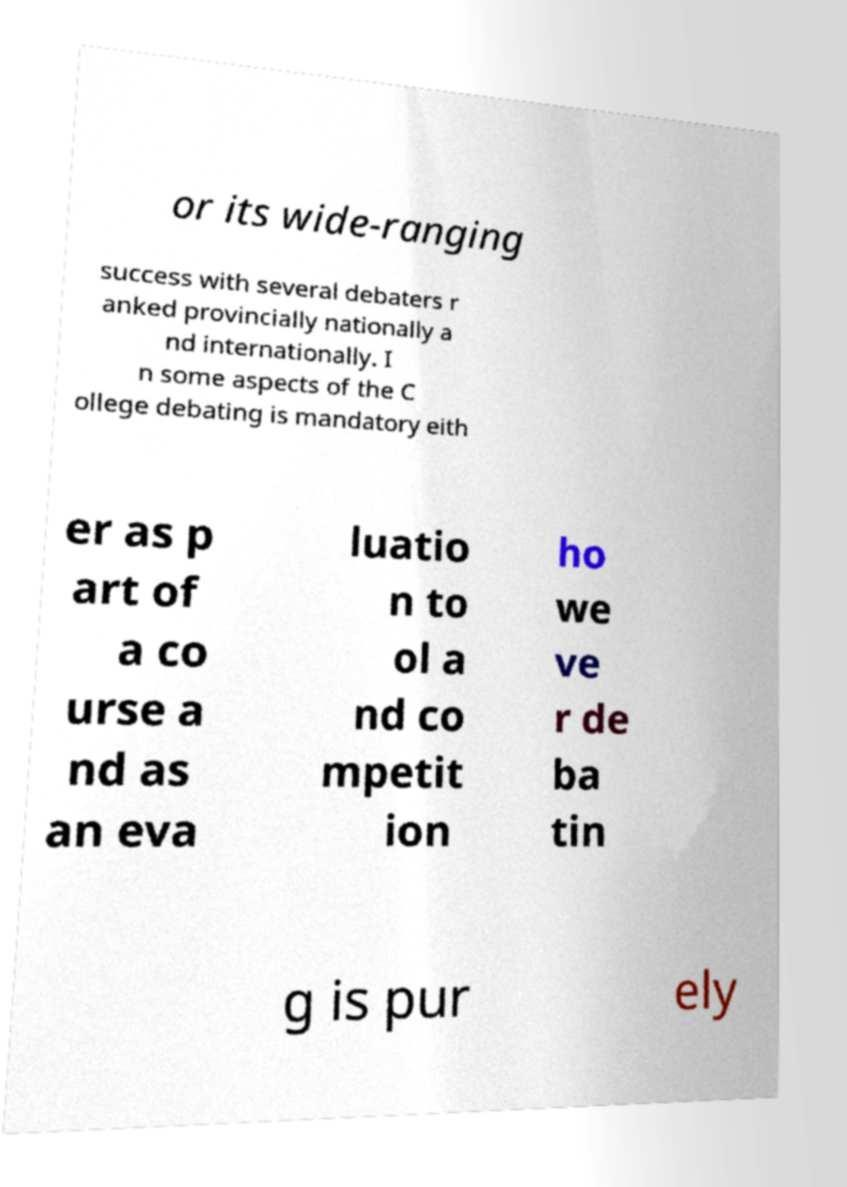What messages or text are displayed in this image? I need them in a readable, typed format. or its wide-ranging success with several debaters r anked provincially nationally a nd internationally. I n some aspects of the C ollege debating is mandatory eith er as p art of a co urse a nd as an eva luatio n to ol a nd co mpetit ion ho we ve r de ba tin g is pur ely 